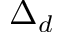<formula> <loc_0><loc_0><loc_500><loc_500>\Delta _ { d }</formula> 